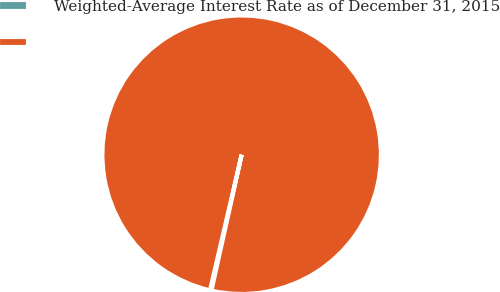Convert chart to OTSL. <chart><loc_0><loc_0><loc_500><loc_500><pie_chart><fcel>Weighted-Average Interest Rate as of December 31, 2015<fcel>Unnamed: 1<nl><fcel>0.17%<fcel>99.83%<nl></chart> 